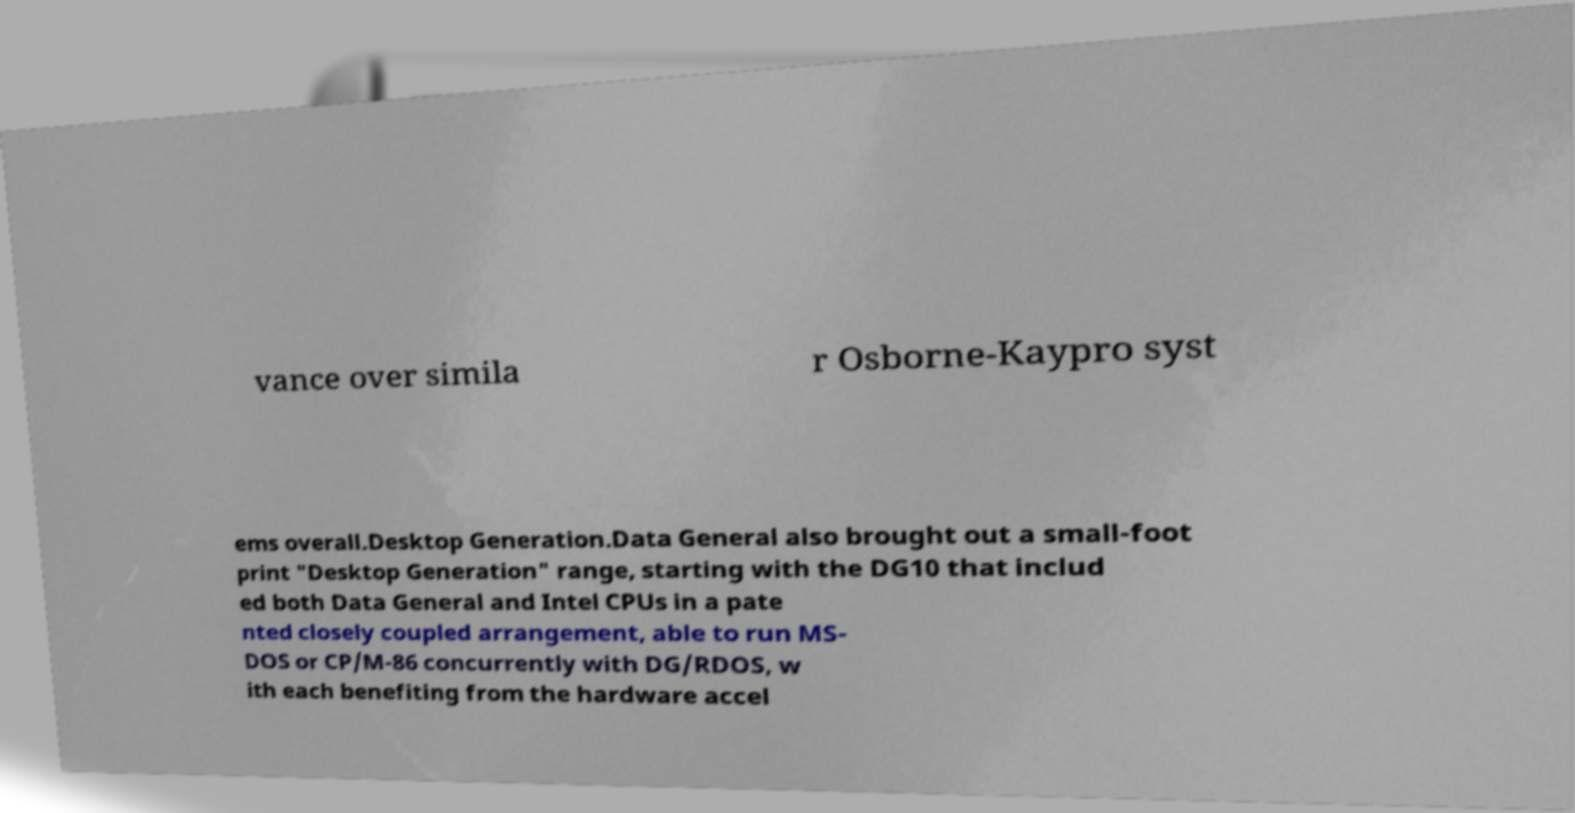Can you read and provide the text displayed in the image?This photo seems to have some interesting text. Can you extract and type it out for me? vance over simila r Osborne-Kaypro syst ems overall.Desktop Generation.Data General also brought out a small-foot print "Desktop Generation" range, starting with the DG10 that includ ed both Data General and Intel CPUs in a pate nted closely coupled arrangement, able to run MS- DOS or CP/M-86 concurrently with DG/RDOS, w ith each benefiting from the hardware accel 